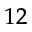<formula> <loc_0><loc_0><loc_500><loc_500>^ { 1 2 }</formula> 